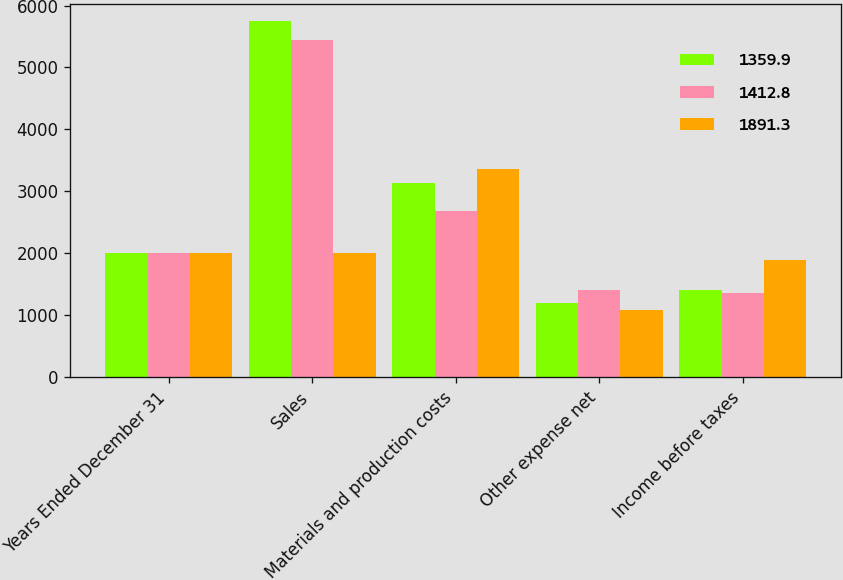<chart> <loc_0><loc_0><loc_500><loc_500><stacked_bar_chart><ecel><fcel>Years Ended December 31<fcel>Sales<fcel>Materials and production costs<fcel>Other expense net<fcel>Income before taxes<nl><fcel>1359.9<fcel>2009<fcel>5743.6<fcel>3136.6<fcel>1194.2<fcel>1412.8<nl><fcel>1412.8<fcel>2008<fcel>5450.4<fcel>2682.4<fcel>1408.1<fcel>1359.9<nl><fcel>1891.3<fcel>2007<fcel>2007.5<fcel>3364<fcel>1090.1<fcel>1891.3<nl></chart> 